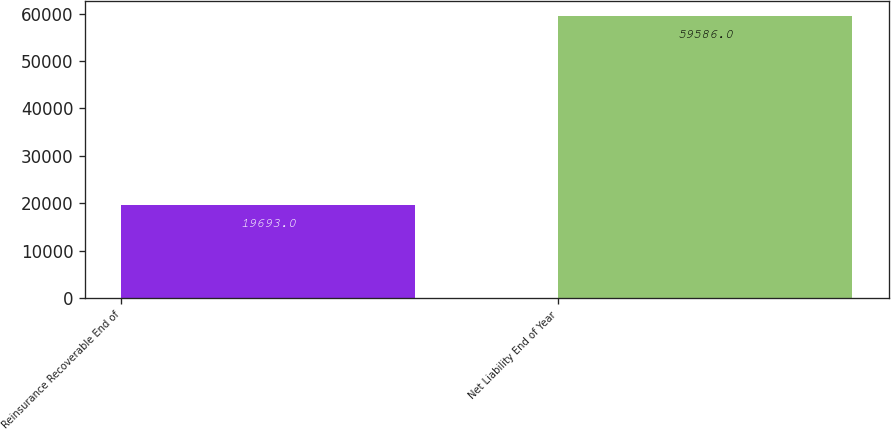<chart> <loc_0><loc_0><loc_500><loc_500><bar_chart><fcel>Reinsurance Recoverable End of<fcel>Net Liability End of Year<nl><fcel>19693<fcel>59586<nl></chart> 